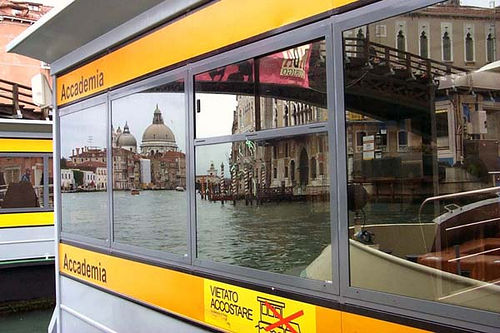Describe any notable architectural elements visible in this image. The image showcases several notable architectural elements including the iconic dome of Basilica di Santa Maria della Salute and the intricate stonework of the surrounding Venetian buildings, reflected in the windows of a boat station. What might you imagine this scene looks like at sunset? At sunset, the scene would be bathed in a warm golden light, casting long shadows over the water. The dome and buildings would glow with a rich orange hue, and the reflections in the windows would shimmer with the colors of the setting sun, creating a breathtaking and serene atmosphere. 